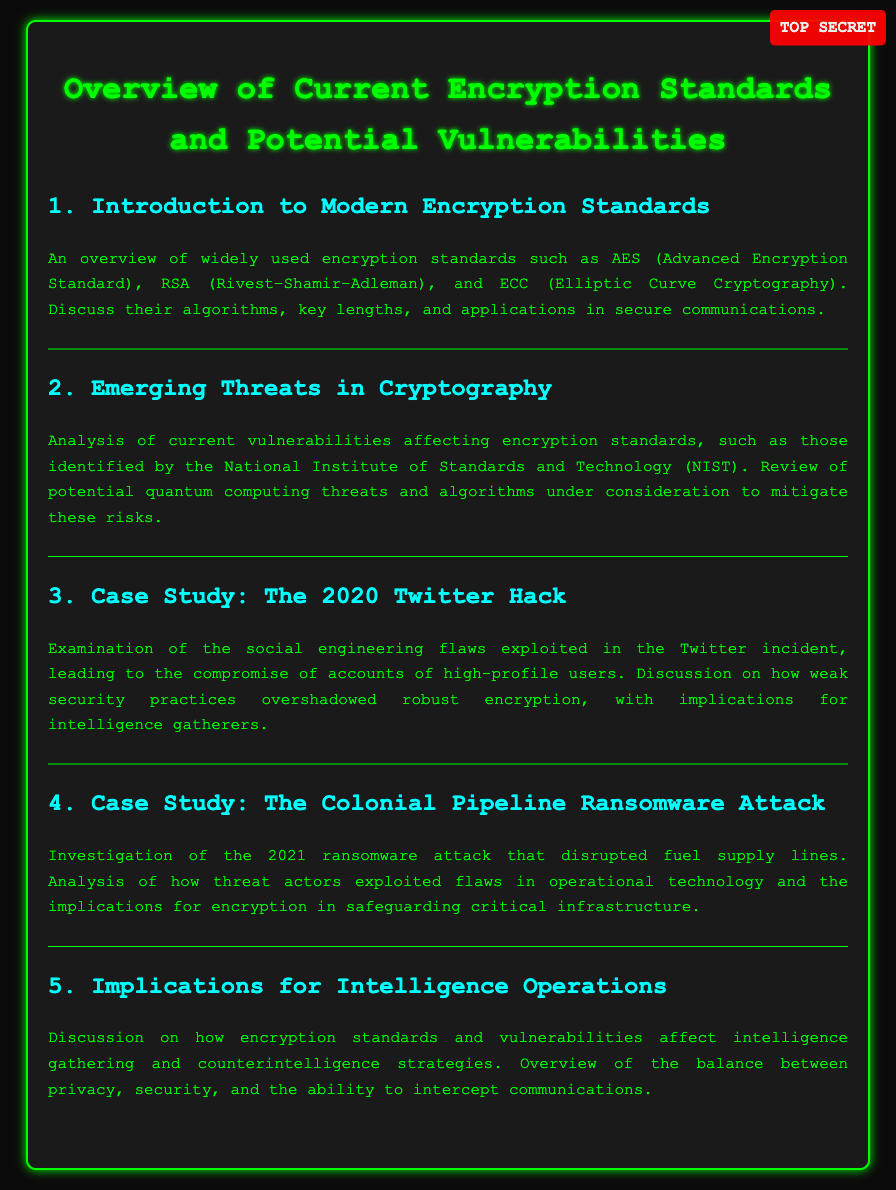What are some encryption standards mentioned? The section titled "Introduction to Modern Encryption Standards" lists AES, RSA, and ECC as widely used encryption standards.
Answer: AES, RSA, ECC What year did the Twitter hack occur? The document specifies the case study "The 2020 Twitter Hack," indicating that the incident occurred in 2020.
Answer: 2020 Which attack disrupted fuel supply lines? The section "Case Study: The Colonial Pipeline Ransomware Attack" refers to an attack that disrupted fuel supply lines.
Answer: Colonial Pipeline Ransomware Attack What does NIST stand for? The mention of NIST in "Emerging Threats in Cryptography" refers to the National Institute of Standards and Technology.
Answer: National Institute of Standards and Technology What does the document suggest is a potential threat to encryption standards? The section "Emerging Threats in Cryptography" mentions quantum computing threats as a potential risk to encryption standards.
Answer: Quantum computing threats What color is the background of the document? The style section of the document sets the body background color to a dark shade, which is specified as #0a0a0a.
Answer: Dark What is the main focus of the section on implications for intelligence operations? The section discusses how encryption standards and vulnerabilities affect intelligence gathering strategies and their balance with privacy and security.
Answer: Intelligence gathering strategies What two elements are analyzed in case study discussions? The case studies investigate social engineering flaws and operational technology flaws, impacting security and encryption applications.
Answer: Social engineering flaws, Operational technology flaws How does the document classify its content? The classified label at the top of the document marks the content as "TOP SECRET."
Answer: TOP SECRET 